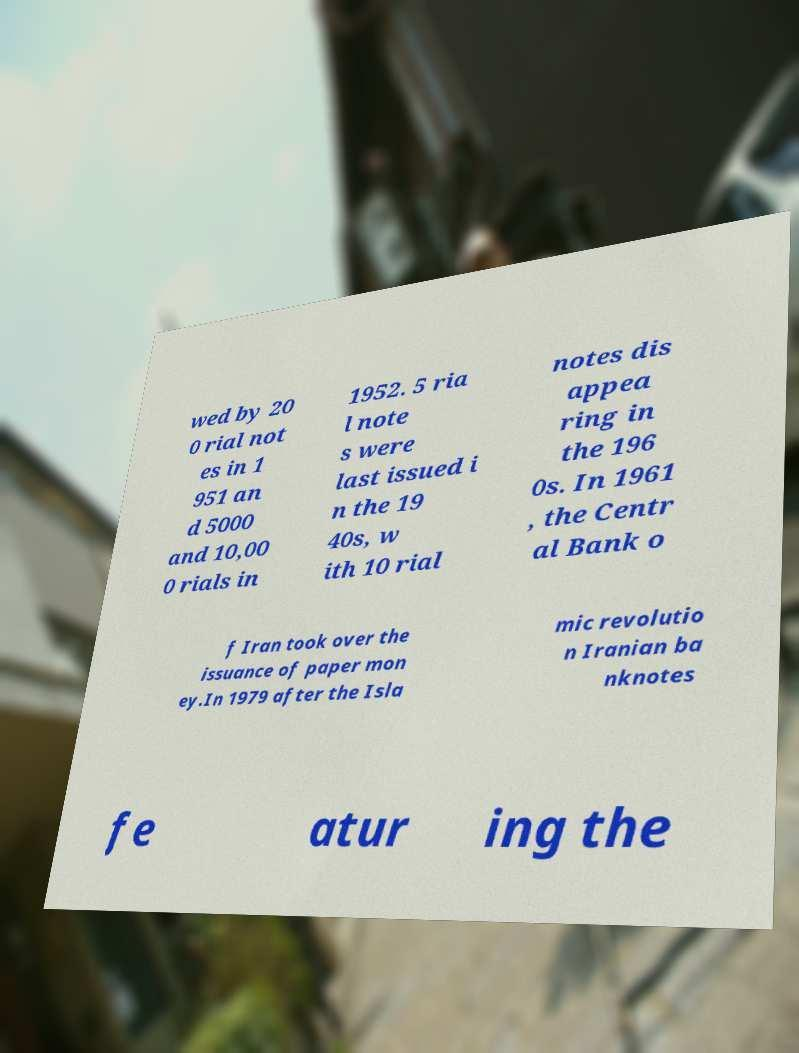There's text embedded in this image that I need extracted. Can you transcribe it verbatim? wed by 20 0 rial not es in 1 951 an d 5000 and 10,00 0 rials in 1952. 5 ria l note s were last issued i n the 19 40s, w ith 10 rial notes dis appea ring in the 196 0s. In 1961 , the Centr al Bank o f Iran took over the issuance of paper mon ey.In 1979 after the Isla mic revolutio n Iranian ba nknotes fe atur ing the 